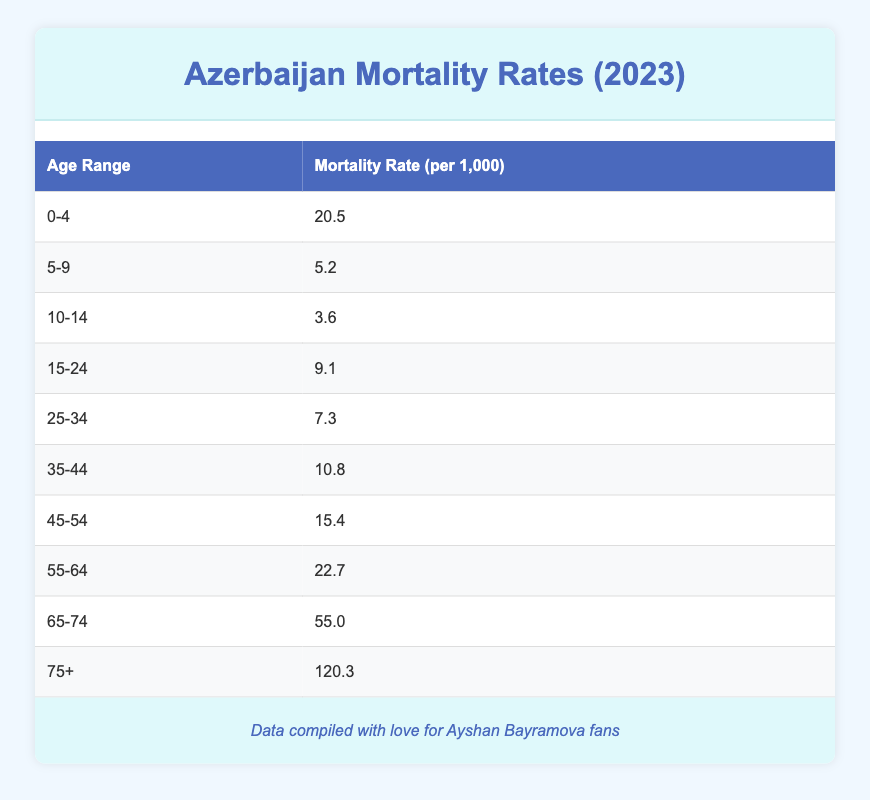What is the mortality rate for the age group 0-4? The table states that the mortality rate for the age group 0-4 is 20.5 per 1,000.
Answer: 20.5 Which age group has the highest mortality rate? The table shows that the age group 75+ has the highest mortality rate at 120.3 per 1,000.
Answer: 75+ What is the difference in mortality rates between the age groups 65-74 and 55-64? The mortality rate for 65-74 is 55.0 and for 55-64 is 22.7. The difference is 55.0 - 22.7 = 32.3.
Answer: 32.3 Is the mortality rate for the age group 15-24 greater than 10 per 1,000? The table indicates that the mortality rate for the age group 15-24 is 9.1 per 1,000, which is not greater than 10.
Answer: No What is the average mortality rate across all age groups listed? To calculate the average, first, sum up all the mortality rates: 20.5 + 5.2 + 3.6 + 9.1 + 7.3 + 10.8 + 15.4 + 22.7 + 55.0 + 120.3 = 249.9. There are 10 age groups, so the average is 249.9 / 10 = 24.99.
Answer: 24.99 Which age group has a mortality rate closest to 10 per 1,000? The age group 25-34 has a mortality rate of 7.3 per 1,000, which is the closest lower value, and the group 35-44 has a rate of 10.8, the closest higher value. Hence, there is no exact match, but these are the closest.
Answer: 25-34 and 35-44 Are mortality rates increasing with age based on the table? By analyzing the rates, they show a clear upward trend with age. For example, the rate goes from 5.2 (5-9) to 120.3 (75+), indicating an increasing pattern.
Answer: Yes What is the total mortality rate for children under 15? To find this, sum the rates for age groups 0-4, 5-9, and 10-14, which are 20.5 + 5.2 + 3.6 = 29.3.
Answer: 29.3 Which age group experienced a mortality rate of less than 10 per 1,000? Looking at the table, the age groups 5-9, 10-14, and 25-34 all show mortality rates less than 10 per 1,000.
Answer: 5-9, 10-14, 25-34 